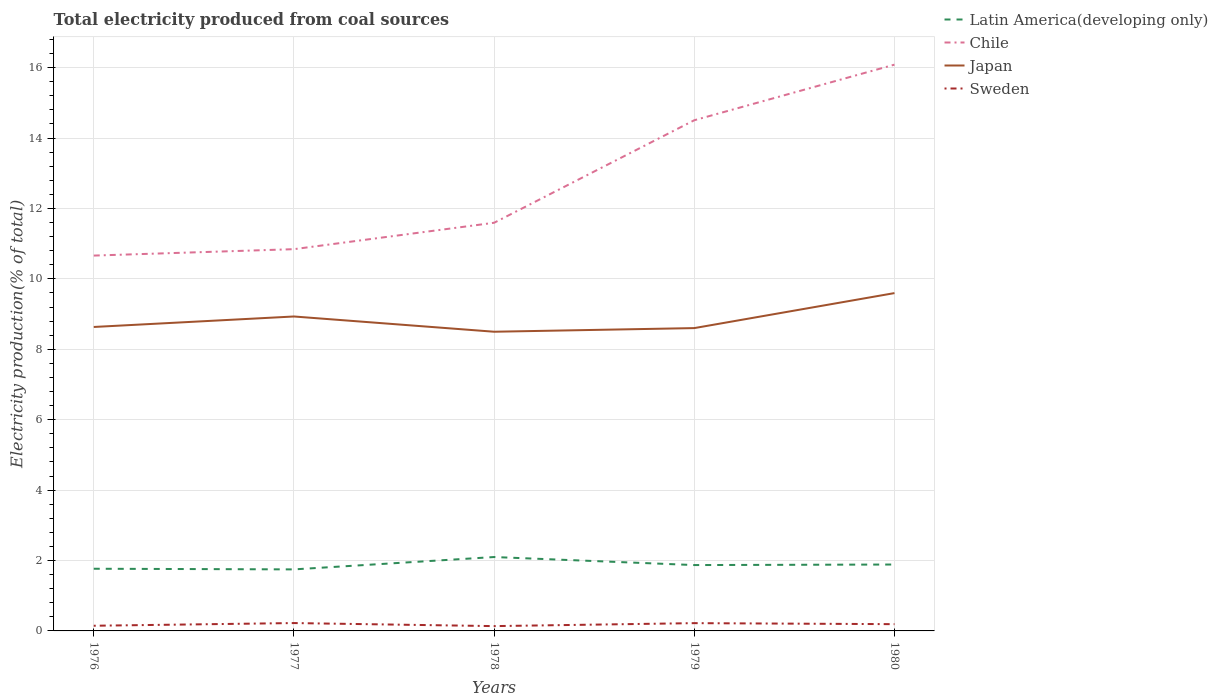Is the number of lines equal to the number of legend labels?
Your answer should be very brief. Yes. Across all years, what is the maximum total electricity produced in Japan?
Your answer should be compact. 8.5. In which year was the total electricity produced in Latin America(developing only) maximum?
Give a very brief answer. 1977. What is the total total electricity produced in Chile in the graph?
Offer a terse response. -0.75. What is the difference between the highest and the second highest total electricity produced in Latin America(developing only)?
Your response must be concise. 0.35. What is the difference between the highest and the lowest total electricity produced in Chile?
Make the answer very short. 2. How many years are there in the graph?
Offer a terse response. 5. What is the difference between two consecutive major ticks on the Y-axis?
Your response must be concise. 2. Are the values on the major ticks of Y-axis written in scientific E-notation?
Your response must be concise. No. Does the graph contain any zero values?
Give a very brief answer. No. How many legend labels are there?
Your response must be concise. 4. How are the legend labels stacked?
Your response must be concise. Vertical. What is the title of the graph?
Keep it short and to the point. Total electricity produced from coal sources. What is the Electricity production(% of total) of Latin America(developing only) in 1976?
Ensure brevity in your answer.  1.77. What is the Electricity production(% of total) in Chile in 1976?
Offer a very short reply. 10.66. What is the Electricity production(% of total) of Japan in 1976?
Offer a terse response. 8.63. What is the Electricity production(% of total) of Sweden in 1976?
Provide a succinct answer. 0.15. What is the Electricity production(% of total) of Latin America(developing only) in 1977?
Provide a short and direct response. 1.75. What is the Electricity production(% of total) in Chile in 1977?
Give a very brief answer. 10.84. What is the Electricity production(% of total) of Japan in 1977?
Provide a succinct answer. 8.93. What is the Electricity production(% of total) of Sweden in 1977?
Keep it short and to the point. 0.22. What is the Electricity production(% of total) of Latin America(developing only) in 1978?
Give a very brief answer. 2.1. What is the Electricity production(% of total) of Chile in 1978?
Provide a short and direct response. 11.59. What is the Electricity production(% of total) in Japan in 1978?
Offer a very short reply. 8.5. What is the Electricity production(% of total) of Sweden in 1978?
Provide a short and direct response. 0.14. What is the Electricity production(% of total) in Latin America(developing only) in 1979?
Offer a terse response. 1.87. What is the Electricity production(% of total) in Chile in 1979?
Provide a short and direct response. 14.51. What is the Electricity production(% of total) of Japan in 1979?
Offer a very short reply. 8.6. What is the Electricity production(% of total) in Sweden in 1979?
Give a very brief answer. 0.22. What is the Electricity production(% of total) in Latin America(developing only) in 1980?
Your answer should be compact. 1.89. What is the Electricity production(% of total) in Chile in 1980?
Your answer should be compact. 16.08. What is the Electricity production(% of total) of Japan in 1980?
Make the answer very short. 9.6. What is the Electricity production(% of total) in Sweden in 1980?
Give a very brief answer. 0.19. Across all years, what is the maximum Electricity production(% of total) of Latin America(developing only)?
Give a very brief answer. 2.1. Across all years, what is the maximum Electricity production(% of total) in Chile?
Provide a short and direct response. 16.08. Across all years, what is the maximum Electricity production(% of total) of Japan?
Offer a terse response. 9.6. Across all years, what is the maximum Electricity production(% of total) in Sweden?
Offer a terse response. 0.22. Across all years, what is the minimum Electricity production(% of total) of Latin America(developing only)?
Your response must be concise. 1.75. Across all years, what is the minimum Electricity production(% of total) in Chile?
Your response must be concise. 10.66. Across all years, what is the minimum Electricity production(% of total) in Japan?
Your response must be concise. 8.5. Across all years, what is the minimum Electricity production(% of total) in Sweden?
Give a very brief answer. 0.14. What is the total Electricity production(% of total) in Latin America(developing only) in the graph?
Your answer should be very brief. 9.37. What is the total Electricity production(% of total) in Chile in the graph?
Your answer should be compact. 63.69. What is the total Electricity production(% of total) of Japan in the graph?
Your answer should be very brief. 44.26. What is the total Electricity production(% of total) in Sweden in the graph?
Keep it short and to the point. 0.92. What is the difference between the Electricity production(% of total) in Latin America(developing only) in 1976 and that in 1977?
Provide a short and direct response. 0.02. What is the difference between the Electricity production(% of total) in Chile in 1976 and that in 1977?
Your response must be concise. -0.18. What is the difference between the Electricity production(% of total) in Japan in 1976 and that in 1977?
Your answer should be compact. -0.3. What is the difference between the Electricity production(% of total) of Sweden in 1976 and that in 1977?
Keep it short and to the point. -0.08. What is the difference between the Electricity production(% of total) in Latin America(developing only) in 1976 and that in 1978?
Your answer should be very brief. -0.33. What is the difference between the Electricity production(% of total) in Chile in 1976 and that in 1978?
Give a very brief answer. -0.93. What is the difference between the Electricity production(% of total) of Japan in 1976 and that in 1978?
Keep it short and to the point. 0.14. What is the difference between the Electricity production(% of total) of Sweden in 1976 and that in 1978?
Provide a succinct answer. 0.01. What is the difference between the Electricity production(% of total) of Latin America(developing only) in 1976 and that in 1979?
Give a very brief answer. -0.1. What is the difference between the Electricity production(% of total) in Chile in 1976 and that in 1979?
Offer a terse response. -3.84. What is the difference between the Electricity production(% of total) of Japan in 1976 and that in 1979?
Keep it short and to the point. 0.03. What is the difference between the Electricity production(% of total) in Sweden in 1976 and that in 1979?
Offer a terse response. -0.07. What is the difference between the Electricity production(% of total) in Latin America(developing only) in 1976 and that in 1980?
Your response must be concise. -0.12. What is the difference between the Electricity production(% of total) of Chile in 1976 and that in 1980?
Provide a short and direct response. -5.42. What is the difference between the Electricity production(% of total) in Japan in 1976 and that in 1980?
Make the answer very short. -0.96. What is the difference between the Electricity production(% of total) of Sweden in 1976 and that in 1980?
Offer a terse response. -0.05. What is the difference between the Electricity production(% of total) of Latin America(developing only) in 1977 and that in 1978?
Ensure brevity in your answer.  -0.35. What is the difference between the Electricity production(% of total) of Chile in 1977 and that in 1978?
Your answer should be very brief. -0.75. What is the difference between the Electricity production(% of total) of Japan in 1977 and that in 1978?
Keep it short and to the point. 0.43. What is the difference between the Electricity production(% of total) in Sweden in 1977 and that in 1978?
Your answer should be very brief. 0.09. What is the difference between the Electricity production(% of total) of Latin America(developing only) in 1977 and that in 1979?
Keep it short and to the point. -0.12. What is the difference between the Electricity production(% of total) in Chile in 1977 and that in 1979?
Offer a very short reply. -3.66. What is the difference between the Electricity production(% of total) in Japan in 1977 and that in 1979?
Provide a short and direct response. 0.33. What is the difference between the Electricity production(% of total) of Sweden in 1977 and that in 1979?
Your answer should be very brief. 0. What is the difference between the Electricity production(% of total) of Latin America(developing only) in 1977 and that in 1980?
Ensure brevity in your answer.  -0.14. What is the difference between the Electricity production(% of total) in Chile in 1977 and that in 1980?
Give a very brief answer. -5.24. What is the difference between the Electricity production(% of total) of Japan in 1977 and that in 1980?
Keep it short and to the point. -0.66. What is the difference between the Electricity production(% of total) of Sweden in 1977 and that in 1980?
Provide a short and direct response. 0.03. What is the difference between the Electricity production(% of total) in Latin America(developing only) in 1978 and that in 1979?
Give a very brief answer. 0.23. What is the difference between the Electricity production(% of total) of Chile in 1978 and that in 1979?
Your answer should be very brief. -2.91. What is the difference between the Electricity production(% of total) of Japan in 1978 and that in 1979?
Ensure brevity in your answer.  -0.1. What is the difference between the Electricity production(% of total) of Sweden in 1978 and that in 1979?
Ensure brevity in your answer.  -0.08. What is the difference between the Electricity production(% of total) in Latin America(developing only) in 1978 and that in 1980?
Your answer should be compact. 0.21. What is the difference between the Electricity production(% of total) of Chile in 1978 and that in 1980?
Offer a very short reply. -4.49. What is the difference between the Electricity production(% of total) in Japan in 1978 and that in 1980?
Keep it short and to the point. -1.1. What is the difference between the Electricity production(% of total) in Sweden in 1978 and that in 1980?
Your response must be concise. -0.06. What is the difference between the Electricity production(% of total) of Latin America(developing only) in 1979 and that in 1980?
Keep it short and to the point. -0.02. What is the difference between the Electricity production(% of total) of Chile in 1979 and that in 1980?
Keep it short and to the point. -1.58. What is the difference between the Electricity production(% of total) in Japan in 1979 and that in 1980?
Ensure brevity in your answer.  -0.99. What is the difference between the Electricity production(% of total) of Sweden in 1979 and that in 1980?
Offer a very short reply. 0.03. What is the difference between the Electricity production(% of total) in Latin America(developing only) in 1976 and the Electricity production(% of total) in Chile in 1977?
Provide a short and direct response. -9.08. What is the difference between the Electricity production(% of total) of Latin America(developing only) in 1976 and the Electricity production(% of total) of Japan in 1977?
Keep it short and to the point. -7.16. What is the difference between the Electricity production(% of total) in Latin America(developing only) in 1976 and the Electricity production(% of total) in Sweden in 1977?
Give a very brief answer. 1.54. What is the difference between the Electricity production(% of total) in Chile in 1976 and the Electricity production(% of total) in Japan in 1977?
Offer a very short reply. 1.73. What is the difference between the Electricity production(% of total) of Chile in 1976 and the Electricity production(% of total) of Sweden in 1977?
Offer a terse response. 10.44. What is the difference between the Electricity production(% of total) of Japan in 1976 and the Electricity production(% of total) of Sweden in 1977?
Your answer should be very brief. 8.41. What is the difference between the Electricity production(% of total) of Latin America(developing only) in 1976 and the Electricity production(% of total) of Chile in 1978?
Provide a succinct answer. -9.83. What is the difference between the Electricity production(% of total) in Latin America(developing only) in 1976 and the Electricity production(% of total) in Japan in 1978?
Provide a succinct answer. -6.73. What is the difference between the Electricity production(% of total) of Latin America(developing only) in 1976 and the Electricity production(% of total) of Sweden in 1978?
Provide a succinct answer. 1.63. What is the difference between the Electricity production(% of total) in Chile in 1976 and the Electricity production(% of total) in Japan in 1978?
Offer a terse response. 2.16. What is the difference between the Electricity production(% of total) of Chile in 1976 and the Electricity production(% of total) of Sweden in 1978?
Ensure brevity in your answer.  10.52. What is the difference between the Electricity production(% of total) of Japan in 1976 and the Electricity production(% of total) of Sweden in 1978?
Offer a very short reply. 8.5. What is the difference between the Electricity production(% of total) in Latin America(developing only) in 1976 and the Electricity production(% of total) in Chile in 1979?
Make the answer very short. -12.74. What is the difference between the Electricity production(% of total) in Latin America(developing only) in 1976 and the Electricity production(% of total) in Japan in 1979?
Your answer should be very brief. -6.83. What is the difference between the Electricity production(% of total) of Latin America(developing only) in 1976 and the Electricity production(% of total) of Sweden in 1979?
Provide a short and direct response. 1.55. What is the difference between the Electricity production(% of total) of Chile in 1976 and the Electricity production(% of total) of Japan in 1979?
Provide a succinct answer. 2.06. What is the difference between the Electricity production(% of total) in Chile in 1976 and the Electricity production(% of total) in Sweden in 1979?
Keep it short and to the point. 10.44. What is the difference between the Electricity production(% of total) in Japan in 1976 and the Electricity production(% of total) in Sweden in 1979?
Keep it short and to the point. 8.41. What is the difference between the Electricity production(% of total) of Latin America(developing only) in 1976 and the Electricity production(% of total) of Chile in 1980?
Ensure brevity in your answer.  -14.32. What is the difference between the Electricity production(% of total) of Latin America(developing only) in 1976 and the Electricity production(% of total) of Japan in 1980?
Keep it short and to the point. -7.83. What is the difference between the Electricity production(% of total) in Latin America(developing only) in 1976 and the Electricity production(% of total) in Sweden in 1980?
Your response must be concise. 1.57. What is the difference between the Electricity production(% of total) of Chile in 1976 and the Electricity production(% of total) of Japan in 1980?
Keep it short and to the point. 1.07. What is the difference between the Electricity production(% of total) in Chile in 1976 and the Electricity production(% of total) in Sweden in 1980?
Provide a short and direct response. 10.47. What is the difference between the Electricity production(% of total) of Japan in 1976 and the Electricity production(% of total) of Sweden in 1980?
Provide a short and direct response. 8.44. What is the difference between the Electricity production(% of total) of Latin America(developing only) in 1977 and the Electricity production(% of total) of Chile in 1978?
Keep it short and to the point. -9.85. What is the difference between the Electricity production(% of total) of Latin America(developing only) in 1977 and the Electricity production(% of total) of Japan in 1978?
Give a very brief answer. -6.75. What is the difference between the Electricity production(% of total) in Latin America(developing only) in 1977 and the Electricity production(% of total) in Sweden in 1978?
Provide a short and direct response. 1.61. What is the difference between the Electricity production(% of total) in Chile in 1977 and the Electricity production(% of total) in Japan in 1978?
Offer a terse response. 2.35. What is the difference between the Electricity production(% of total) of Chile in 1977 and the Electricity production(% of total) of Sweden in 1978?
Offer a terse response. 10.71. What is the difference between the Electricity production(% of total) of Japan in 1977 and the Electricity production(% of total) of Sweden in 1978?
Make the answer very short. 8.79. What is the difference between the Electricity production(% of total) in Latin America(developing only) in 1977 and the Electricity production(% of total) in Chile in 1979?
Make the answer very short. -12.76. What is the difference between the Electricity production(% of total) in Latin America(developing only) in 1977 and the Electricity production(% of total) in Japan in 1979?
Offer a very short reply. -6.85. What is the difference between the Electricity production(% of total) of Latin America(developing only) in 1977 and the Electricity production(% of total) of Sweden in 1979?
Your answer should be very brief. 1.53. What is the difference between the Electricity production(% of total) of Chile in 1977 and the Electricity production(% of total) of Japan in 1979?
Make the answer very short. 2.24. What is the difference between the Electricity production(% of total) of Chile in 1977 and the Electricity production(% of total) of Sweden in 1979?
Provide a succinct answer. 10.62. What is the difference between the Electricity production(% of total) in Japan in 1977 and the Electricity production(% of total) in Sweden in 1979?
Make the answer very short. 8.71. What is the difference between the Electricity production(% of total) in Latin America(developing only) in 1977 and the Electricity production(% of total) in Chile in 1980?
Your response must be concise. -14.34. What is the difference between the Electricity production(% of total) of Latin America(developing only) in 1977 and the Electricity production(% of total) of Japan in 1980?
Your answer should be very brief. -7.85. What is the difference between the Electricity production(% of total) of Latin America(developing only) in 1977 and the Electricity production(% of total) of Sweden in 1980?
Provide a short and direct response. 1.56. What is the difference between the Electricity production(% of total) of Chile in 1977 and the Electricity production(% of total) of Japan in 1980?
Your answer should be compact. 1.25. What is the difference between the Electricity production(% of total) of Chile in 1977 and the Electricity production(% of total) of Sweden in 1980?
Provide a succinct answer. 10.65. What is the difference between the Electricity production(% of total) of Japan in 1977 and the Electricity production(% of total) of Sweden in 1980?
Offer a very short reply. 8.74. What is the difference between the Electricity production(% of total) in Latin America(developing only) in 1978 and the Electricity production(% of total) in Chile in 1979?
Offer a very short reply. -12.41. What is the difference between the Electricity production(% of total) of Latin America(developing only) in 1978 and the Electricity production(% of total) of Japan in 1979?
Your answer should be very brief. -6.5. What is the difference between the Electricity production(% of total) of Latin America(developing only) in 1978 and the Electricity production(% of total) of Sweden in 1979?
Provide a succinct answer. 1.88. What is the difference between the Electricity production(% of total) of Chile in 1978 and the Electricity production(% of total) of Japan in 1979?
Your response must be concise. 2.99. What is the difference between the Electricity production(% of total) in Chile in 1978 and the Electricity production(% of total) in Sweden in 1979?
Provide a short and direct response. 11.37. What is the difference between the Electricity production(% of total) in Japan in 1978 and the Electricity production(% of total) in Sweden in 1979?
Your answer should be compact. 8.28. What is the difference between the Electricity production(% of total) in Latin America(developing only) in 1978 and the Electricity production(% of total) in Chile in 1980?
Keep it short and to the point. -13.98. What is the difference between the Electricity production(% of total) in Latin America(developing only) in 1978 and the Electricity production(% of total) in Japan in 1980?
Ensure brevity in your answer.  -7.5. What is the difference between the Electricity production(% of total) in Latin America(developing only) in 1978 and the Electricity production(% of total) in Sweden in 1980?
Your response must be concise. 1.91. What is the difference between the Electricity production(% of total) of Chile in 1978 and the Electricity production(% of total) of Japan in 1980?
Give a very brief answer. 2. What is the difference between the Electricity production(% of total) in Chile in 1978 and the Electricity production(% of total) in Sweden in 1980?
Provide a short and direct response. 11.4. What is the difference between the Electricity production(% of total) of Japan in 1978 and the Electricity production(% of total) of Sweden in 1980?
Your response must be concise. 8.31. What is the difference between the Electricity production(% of total) in Latin America(developing only) in 1979 and the Electricity production(% of total) in Chile in 1980?
Make the answer very short. -14.21. What is the difference between the Electricity production(% of total) in Latin America(developing only) in 1979 and the Electricity production(% of total) in Japan in 1980?
Provide a succinct answer. -7.72. What is the difference between the Electricity production(% of total) in Latin America(developing only) in 1979 and the Electricity production(% of total) in Sweden in 1980?
Your answer should be compact. 1.68. What is the difference between the Electricity production(% of total) in Chile in 1979 and the Electricity production(% of total) in Japan in 1980?
Offer a very short reply. 4.91. What is the difference between the Electricity production(% of total) of Chile in 1979 and the Electricity production(% of total) of Sweden in 1980?
Provide a short and direct response. 14.31. What is the difference between the Electricity production(% of total) in Japan in 1979 and the Electricity production(% of total) in Sweden in 1980?
Give a very brief answer. 8.41. What is the average Electricity production(% of total) in Latin America(developing only) per year?
Ensure brevity in your answer.  1.87. What is the average Electricity production(% of total) in Chile per year?
Ensure brevity in your answer.  12.74. What is the average Electricity production(% of total) of Japan per year?
Provide a succinct answer. 8.85. What is the average Electricity production(% of total) in Sweden per year?
Your answer should be compact. 0.18. In the year 1976, what is the difference between the Electricity production(% of total) of Latin America(developing only) and Electricity production(% of total) of Chile?
Give a very brief answer. -8.89. In the year 1976, what is the difference between the Electricity production(% of total) of Latin America(developing only) and Electricity production(% of total) of Japan?
Your answer should be compact. -6.87. In the year 1976, what is the difference between the Electricity production(% of total) of Latin America(developing only) and Electricity production(% of total) of Sweden?
Your answer should be very brief. 1.62. In the year 1976, what is the difference between the Electricity production(% of total) of Chile and Electricity production(% of total) of Japan?
Give a very brief answer. 2.03. In the year 1976, what is the difference between the Electricity production(% of total) of Chile and Electricity production(% of total) of Sweden?
Give a very brief answer. 10.51. In the year 1976, what is the difference between the Electricity production(% of total) of Japan and Electricity production(% of total) of Sweden?
Make the answer very short. 8.49. In the year 1977, what is the difference between the Electricity production(% of total) of Latin America(developing only) and Electricity production(% of total) of Chile?
Make the answer very short. -9.1. In the year 1977, what is the difference between the Electricity production(% of total) of Latin America(developing only) and Electricity production(% of total) of Japan?
Make the answer very short. -7.18. In the year 1977, what is the difference between the Electricity production(% of total) in Latin America(developing only) and Electricity production(% of total) in Sweden?
Provide a succinct answer. 1.52. In the year 1977, what is the difference between the Electricity production(% of total) in Chile and Electricity production(% of total) in Japan?
Make the answer very short. 1.91. In the year 1977, what is the difference between the Electricity production(% of total) in Chile and Electricity production(% of total) in Sweden?
Your answer should be compact. 10.62. In the year 1977, what is the difference between the Electricity production(% of total) in Japan and Electricity production(% of total) in Sweden?
Give a very brief answer. 8.71. In the year 1978, what is the difference between the Electricity production(% of total) in Latin America(developing only) and Electricity production(% of total) in Chile?
Your answer should be compact. -9.49. In the year 1978, what is the difference between the Electricity production(% of total) of Latin America(developing only) and Electricity production(% of total) of Japan?
Offer a terse response. -6.4. In the year 1978, what is the difference between the Electricity production(% of total) in Latin America(developing only) and Electricity production(% of total) in Sweden?
Provide a succinct answer. 1.96. In the year 1978, what is the difference between the Electricity production(% of total) of Chile and Electricity production(% of total) of Japan?
Offer a very short reply. 3.09. In the year 1978, what is the difference between the Electricity production(% of total) of Chile and Electricity production(% of total) of Sweden?
Make the answer very short. 11.46. In the year 1978, what is the difference between the Electricity production(% of total) in Japan and Electricity production(% of total) in Sweden?
Keep it short and to the point. 8.36. In the year 1979, what is the difference between the Electricity production(% of total) in Latin America(developing only) and Electricity production(% of total) in Chile?
Provide a succinct answer. -12.63. In the year 1979, what is the difference between the Electricity production(% of total) in Latin America(developing only) and Electricity production(% of total) in Japan?
Give a very brief answer. -6.73. In the year 1979, what is the difference between the Electricity production(% of total) in Latin America(developing only) and Electricity production(% of total) in Sweden?
Keep it short and to the point. 1.65. In the year 1979, what is the difference between the Electricity production(% of total) in Chile and Electricity production(% of total) in Japan?
Make the answer very short. 5.9. In the year 1979, what is the difference between the Electricity production(% of total) of Chile and Electricity production(% of total) of Sweden?
Give a very brief answer. 14.28. In the year 1979, what is the difference between the Electricity production(% of total) of Japan and Electricity production(% of total) of Sweden?
Your answer should be very brief. 8.38. In the year 1980, what is the difference between the Electricity production(% of total) in Latin America(developing only) and Electricity production(% of total) in Chile?
Keep it short and to the point. -14.2. In the year 1980, what is the difference between the Electricity production(% of total) in Latin America(developing only) and Electricity production(% of total) in Japan?
Offer a terse response. -7.71. In the year 1980, what is the difference between the Electricity production(% of total) of Latin America(developing only) and Electricity production(% of total) of Sweden?
Your answer should be very brief. 1.69. In the year 1980, what is the difference between the Electricity production(% of total) in Chile and Electricity production(% of total) in Japan?
Your answer should be very brief. 6.49. In the year 1980, what is the difference between the Electricity production(% of total) in Chile and Electricity production(% of total) in Sweden?
Give a very brief answer. 15.89. In the year 1980, what is the difference between the Electricity production(% of total) of Japan and Electricity production(% of total) of Sweden?
Keep it short and to the point. 9.4. What is the ratio of the Electricity production(% of total) in Latin America(developing only) in 1976 to that in 1977?
Provide a succinct answer. 1.01. What is the ratio of the Electricity production(% of total) of Chile in 1976 to that in 1977?
Offer a terse response. 0.98. What is the ratio of the Electricity production(% of total) in Japan in 1976 to that in 1977?
Offer a terse response. 0.97. What is the ratio of the Electricity production(% of total) of Sweden in 1976 to that in 1977?
Ensure brevity in your answer.  0.66. What is the ratio of the Electricity production(% of total) of Latin America(developing only) in 1976 to that in 1978?
Your response must be concise. 0.84. What is the ratio of the Electricity production(% of total) in Chile in 1976 to that in 1978?
Make the answer very short. 0.92. What is the ratio of the Electricity production(% of total) of Japan in 1976 to that in 1978?
Offer a terse response. 1.02. What is the ratio of the Electricity production(% of total) of Sweden in 1976 to that in 1978?
Your answer should be compact. 1.08. What is the ratio of the Electricity production(% of total) in Latin America(developing only) in 1976 to that in 1979?
Your response must be concise. 0.94. What is the ratio of the Electricity production(% of total) in Chile in 1976 to that in 1979?
Your answer should be compact. 0.73. What is the ratio of the Electricity production(% of total) in Japan in 1976 to that in 1979?
Your answer should be very brief. 1. What is the ratio of the Electricity production(% of total) in Sweden in 1976 to that in 1979?
Your answer should be very brief. 0.67. What is the ratio of the Electricity production(% of total) in Latin America(developing only) in 1976 to that in 1980?
Provide a short and direct response. 0.94. What is the ratio of the Electricity production(% of total) of Chile in 1976 to that in 1980?
Provide a succinct answer. 0.66. What is the ratio of the Electricity production(% of total) in Japan in 1976 to that in 1980?
Give a very brief answer. 0.9. What is the ratio of the Electricity production(% of total) in Sweden in 1976 to that in 1980?
Your response must be concise. 0.77. What is the ratio of the Electricity production(% of total) in Latin America(developing only) in 1977 to that in 1978?
Give a very brief answer. 0.83. What is the ratio of the Electricity production(% of total) in Chile in 1977 to that in 1978?
Your response must be concise. 0.94. What is the ratio of the Electricity production(% of total) of Japan in 1977 to that in 1978?
Your answer should be compact. 1.05. What is the ratio of the Electricity production(% of total) of Sweden in 1977 to that in 1978?
Provide a short and direct response. 1.63. What is the ratio of the Electricity production(% of total) of Latin America(developing only) in 1977 to that in 1979?
Your answer should be very brief. 0.93. What is the ratio of the Electricity production(% of total) of Chile in 1977 to that in 1979?
Offer a very short reply. 0.75. What is the ratio of the Electricity production(% of total) in Japan in 1977 to that in 1979?
Give a very brief answer. 1.04. What is the ratio of the Electricity production(% of total) of Sweden in 1977 to that in 1979?
Provide a short and direct response. 1.01. What is the ratio of the Electricity production(% of total) in Latin America(developing only) in 1977 to that in 1980?
Make the answer very short. 0.93. What is the ratio of the Electricity production(% of total) of Chile in 1977 to that in 1980?
Offer a terse response. 0.67. What is the ratio of the Electricity production(% of total) of Japan in 1977 to that in 1980?
Offer a terse response. 0.93. What is the ratio of the Electricity production(% of total) of Sweden in 1977 to that in 1980?
Provide a short and direct response. 1.16. What is the ratio of the Electricity production(% of total) of Latin America(developing only) in 1978 to that in 1979?
Offer a terse response. 1.12. What is the ratio of the Electricity production(% of total) in Chile in 1978 to that in 1979?
Your answer should be compact. 0.8. What is the ratio of the Electricity production(% of total) of Japan in 1978 to that in 1979?
Offer a very short reply. 0.99. What is the ratio of the Electricity production(% of total) in Sweden in 1978 to that in 1979?
Make the answer very short. 0.62. What is the ratio of the Electricity production(% of total) in Latin America(developing only) in 1978 to that in 1980?
Keep it short and to the point. 1.11. What is the ratio of the Electricity production(% of total) in Chile in 1978 to that in 1980?
Your answer should be compact. 0.72. What is the ratio of the Electricity production(% of total) of Japan in 1978 to that in 1980?
Offer a terse response. 0.89. What is the ratio of the Electricity production(% of total) of Sweden in 1978 to that in 1980?
Offer a very short reply. 0.71. What is the ratio of the Electricity production(% of total) in Chile in 1979 to that in 1980?
Give a very brief answer. 0.9. What is the ratio of the Electricity production(% of total) of Japan in 1979 to that in 1980?
Your answer should be compact. 0.9. What is the ratio of the Electricity production(% of total) in Sweden in 1979 to that in 1980?
Provide a succinct answer. 1.15. What is the difference between the highest and the second highest Electricity production(% of total) of Latin America(developing only)?
Ensure brevity in your answer.  0.21. What is the difference between the highest and the second highest Electricity production(% of total) in Chile?
Make the answer very short. 1.58. What is the difference between the highest and the second highest Electricity production(% of total) in Japan?
Offer a very short reply. 0.66. What is the difference between the highest and the second highest Electricity production(% of total) in Sweden?
Provide a short and direct response. 0. What is the difference between the highest and the lowest Electricity production(% of total) in Latin America(developing only)?
Ensure brevity in your answer.  0.35. What is the difference between the highest and the lowest Electricity production(% of total) in Chile?
Your answer should be compact. 5.42. What is the difference between the highest and the lowest Electricity production(% of total) in Japan?
Your answer should be very brief. 1.1. What is the difference between the highest and the lowest Electricity production(% of total) in Sweden?
Your answer should be very brief. 0.09. 